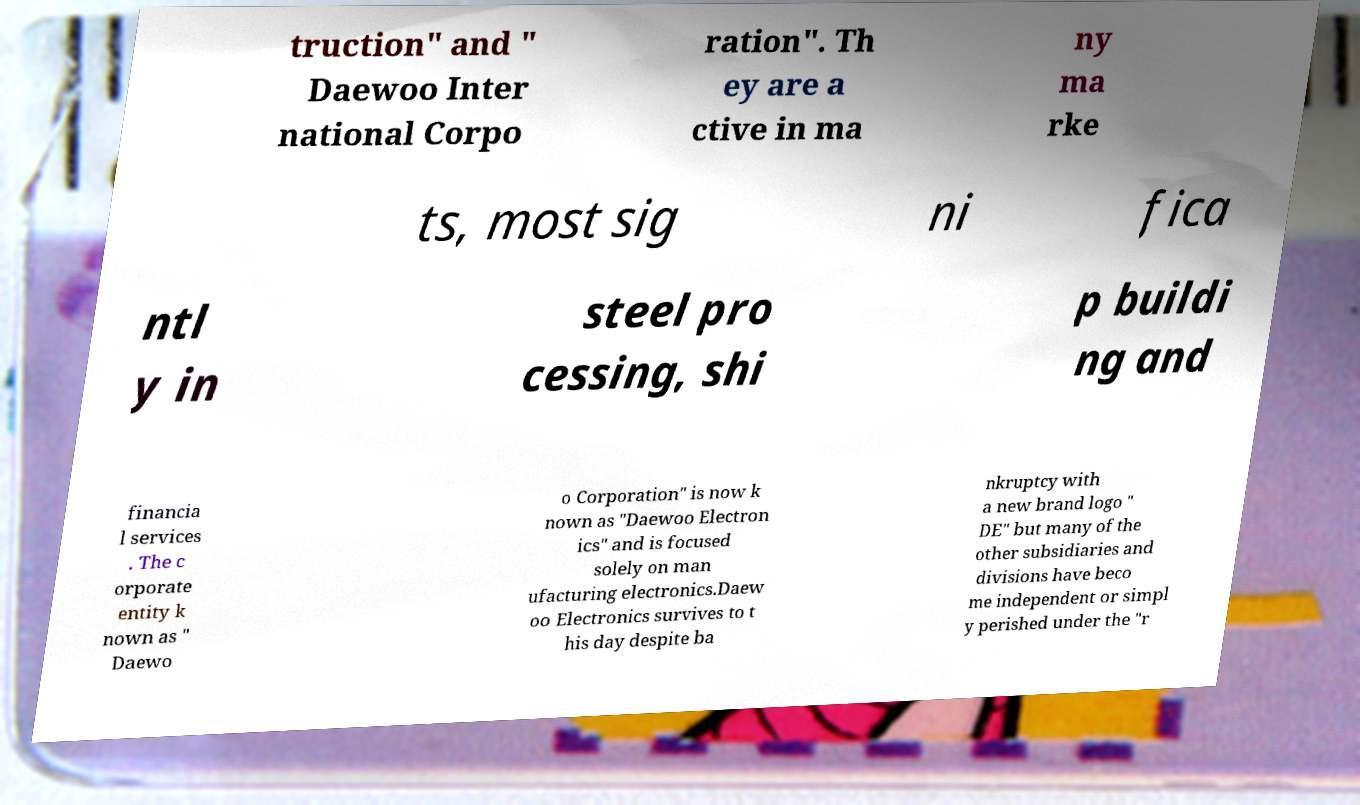I need the written content from this picture converted into text. Can you do that? truction" and " Daewoo Inter national Corpo ration". Th ey are a ctive in ma ny ma rke ts, most sig ni fica ntl y in steel pro cessing, shi p buildi ng and financia l services . The c orporate entity k nown as " Daewo o Corporation" is now k nown as "Daewoo Electron ics" and is focused solely on man ufacturing electronics.Daew oo Electronics survives to t his day despite ba nkruptcy with a new brand logo " DE" but many of the other subsidiaries and divisions have beco me independent or simpl y perished under the "r 